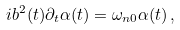Convert formula to latex. <formula><loc_0><loc_0><loc_500><loc_500>i b ^ { 2 } ( t ) \partial _ { t } \alpha ( t ) = \omega _ { n 0 } \alpha ( t ) \, ,</formula> 